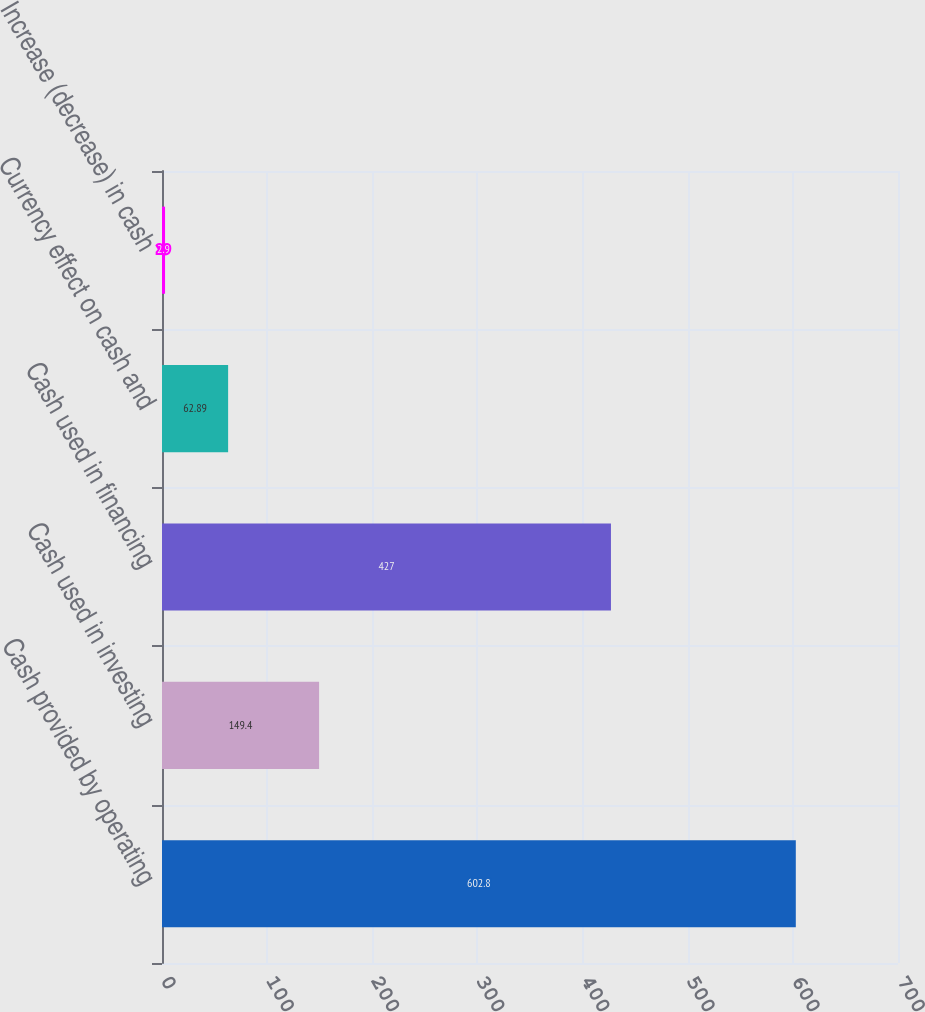Convert chart. <chart><loc_0><loc_0><loc_500><loc_500><bar_chart><fcel>Cash provided by operating<fcel>Cash used in investing<fcel>Cash used in financing<fcel>Currency effect on cash and<fcel>Increase (decrease) in cash<nl><fcel>602.8<fcel>149.4<fcel>427<fcel>62.89<fcel>2.9<nl></chart> 